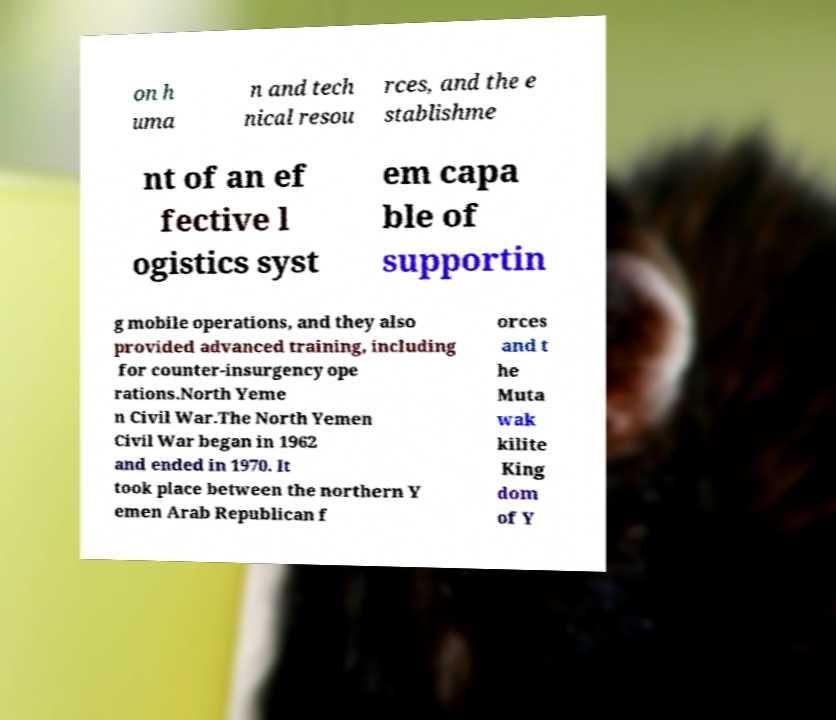For documentation purposes, I need the text within this image transcribed. Could you provide that? on h uma n and tech nical resou rces, and the e stablishme nt of an ef fective l ogistics syst em capa ble of supportin g mobile operations, and they also provided advanced training, including for counter-insurgency ope rations.North Yeme n Civil War.The North Yemen Civil War began in 1962 and ended in 1970. It took place between the northern Y emen Arab Republican f orces and t he Muta wak kilite King dom of Y 